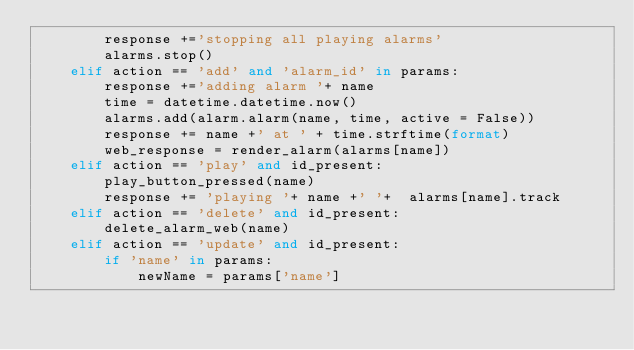<code> <loc_0><loc_0><loc_500><loc_500><_Python_>        response +='stopping all playing alarms'
        alarms.stop()
    elif action == 'add' and 'alarm_id' in params:
        response +='adding alarm '+ name
        time = datetime.datetime.now()
        alarms.add(alarm.alarm(name, time, active = False))
        response += name +' at ' + time.strftime(format)
        web_response = render_alarm(alarms[name])
    elif action == 'play' and id_present:
        play_button_pressed(name)
        response += 'playing '+ name +' '+  alarms[name].track
    elif action == 'delete' and id_present:
        delete_alarm_web(name)
    elif action == 'update' and id_present:
        if 'name' in params:
            newName = params['name']</code> 